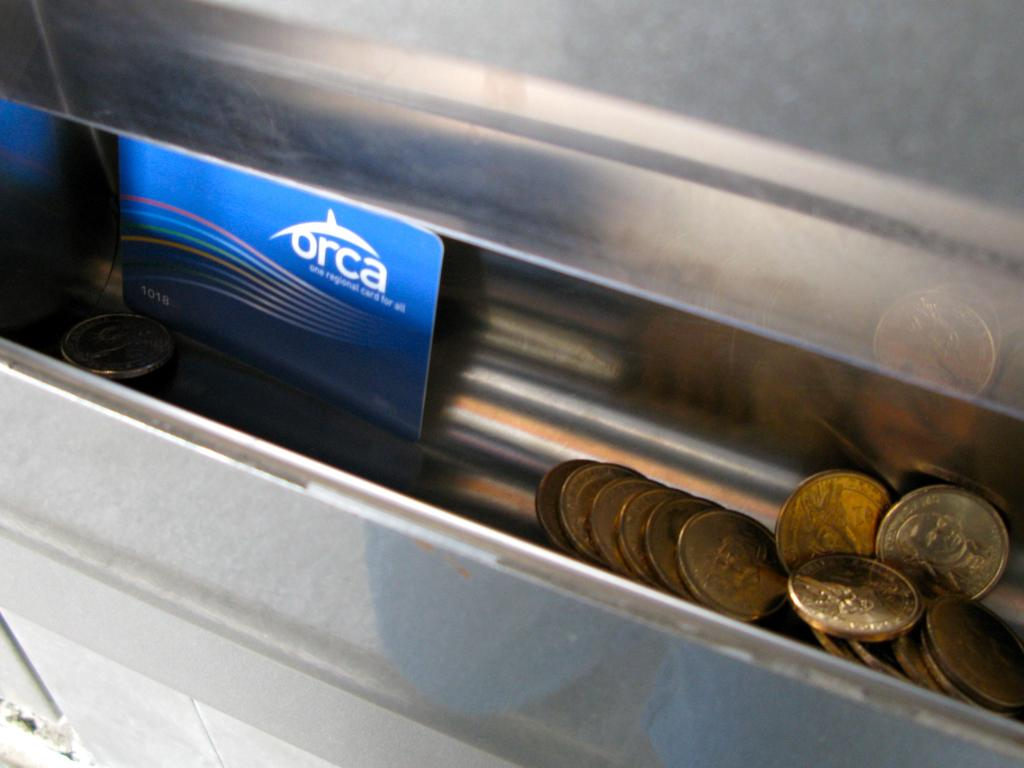<image>
Relay a brief, clear account of the picture shown. an Orca card is in the change container 